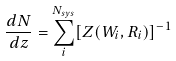Convert formula to latex. <formula><loc_0><loc_0><loc_500><loc_500>\frac { d N } { d z } = \sum _ { i } ^ { N _ { s y s } } [ Z ( W _ { i } , R _ { i } ) ] ^ { - 1 }</formula> 